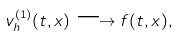Convert formula to latex. <formula><loc_0><loc_0><loc_500><loc_500>v _ { h } ^ { ( 1 ) } ( t , x ) \longrightarrow f ( t , x ) ,</formula> 